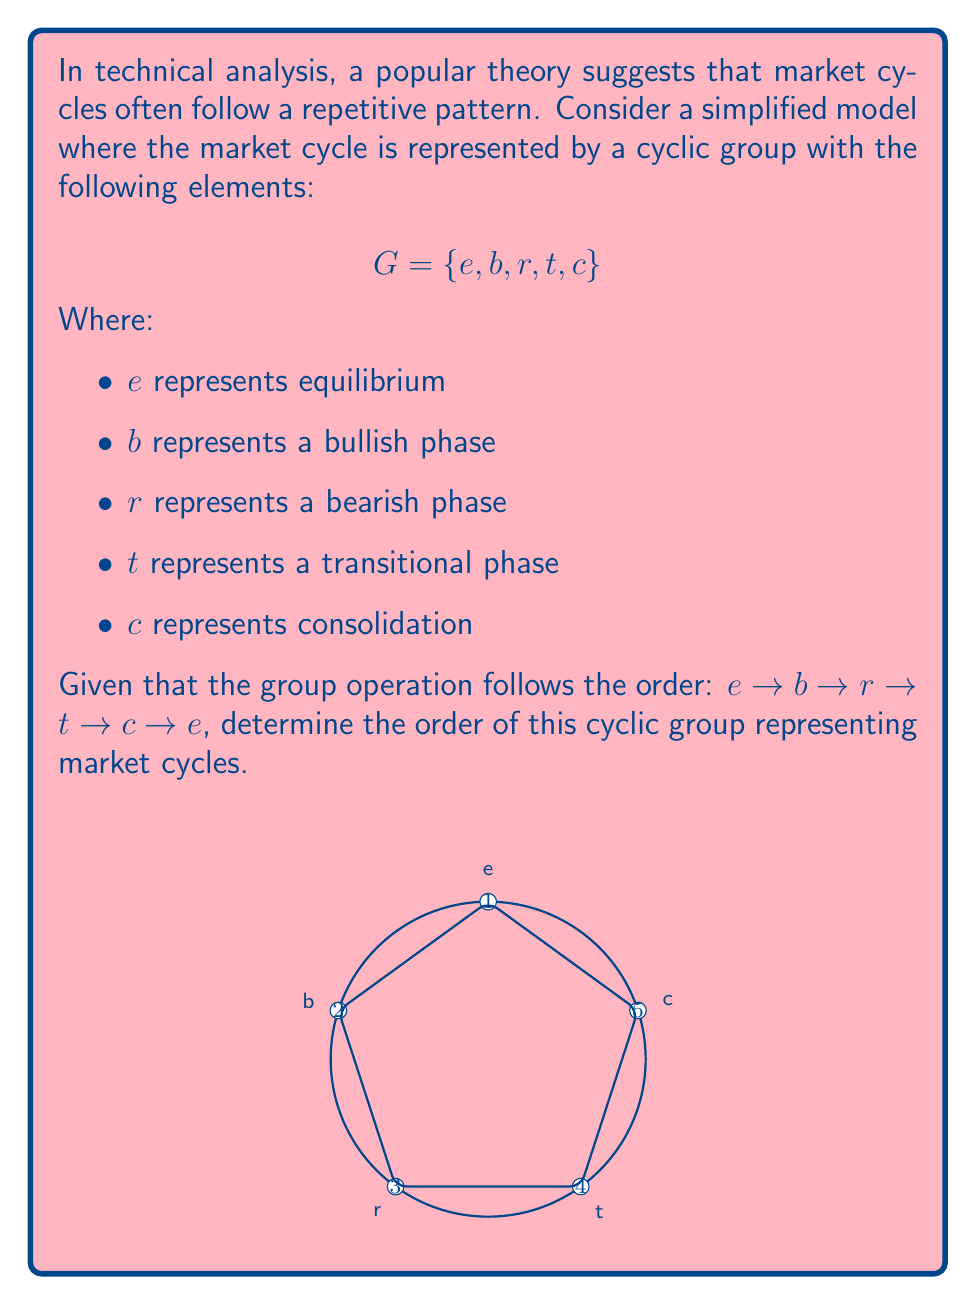Could you help me with this problem? To determine the order of a cyclic group, we need to find the smallest positive integer $n$ such that $g^n = e$ for any generator $g$ of the group.

Let's follow the steps:

1) First, we need to identify a generator. In this case, any element other than $e$ can be a generator. Let's choose $b$ as our generator.

2) Now, let's apply the operation repeatedly starting from $b$:
   $b^1 = b$
   $b^2 = r$
   $b^3 = t$
   $b^4 = c$
   $b^5 = e$

3) We see that $b^5 = e$, which means that after applying the operation 5 times, we return to the identity element.

4) This is true for any element in the group. For example:
   $r^1 = r$
   $r^2 = t$
   $r^3 = c$
   $r^4 = e$
   $r^5 = b$

5) The smallest positive integer $n$ such that $g^n = e$ for any $g$ in the group is 5.

Therefore, the order of this cyclic group is 5.

In the context of market cycles, this means that the simplified model suggests a complete market cycle goes through 5 distinct phases before repeating.
Answer: 5 